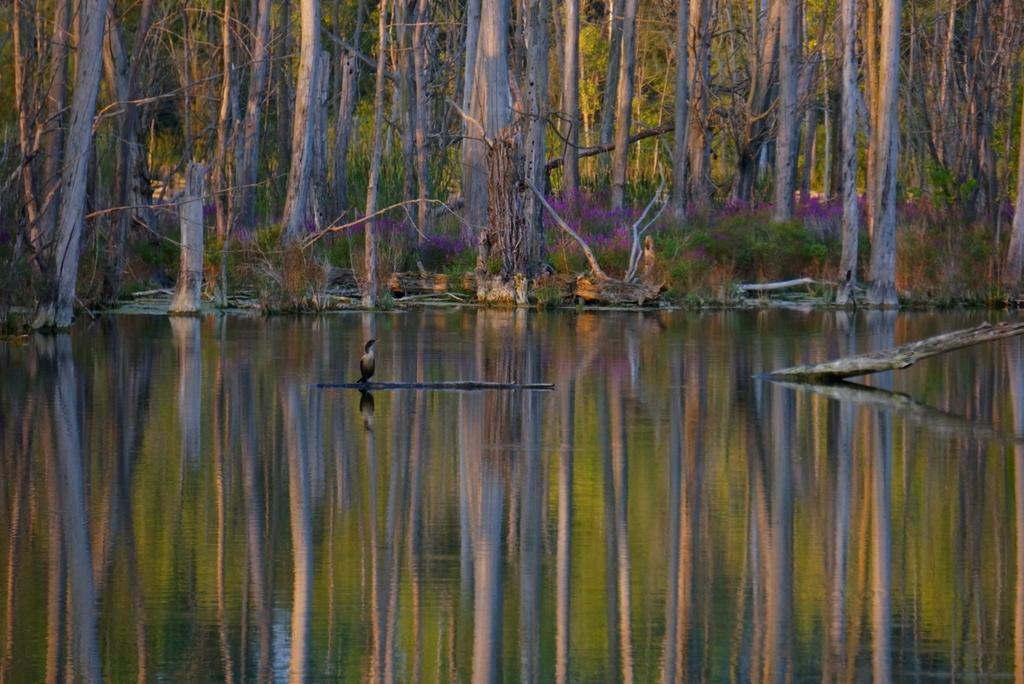What animal can be seen in the image? There is a bird in the image. Where is the bird located? The bird is on a branch. What is the branch resting on? The branch is on the water surface. What can be seen in the background of the image? There are trees in the background of the image. What is the color of the trees? The trees are green in color. Can you see any clouds in the image? There is no mention of clouds in the provided facts, and therefore we cannot determine if clouds are present in the image. 